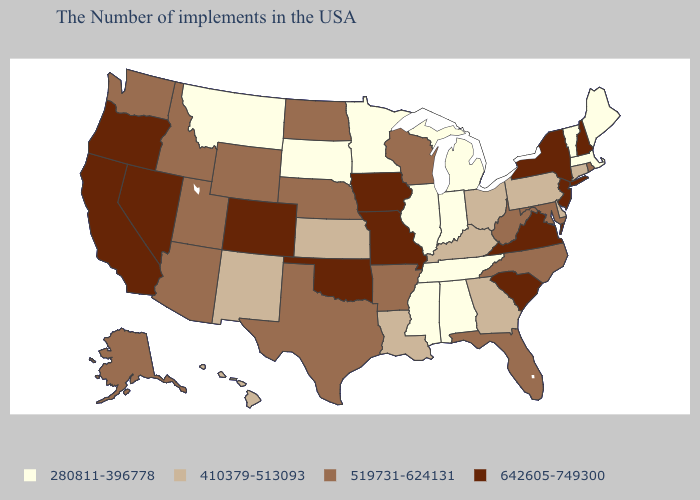What is the highest value in states that border Texas?
Keep it brief. 642605-749300. Name the states that have a value in the range 642605-749300?
Write a very short answer. New Hampshire, New York, New Jersey, Virginia, South Carolina, Missouri, Iowa, Oklahoma, Colorado, Nevada, California, Oregon. Does Virginia have the highest value in the USA?
Concise answer only. Yes. What is the value of New Jersey?
Write a very short answer. 642605-749300. Does Delaware have a higher value than Pennsylvania?
Be succinct. No. What is the value of California?
Quick response, please. 642605-749300. What is the value of Nebraska?
Concise answer only. 519731-624131. What is the value of Alabama?
Answer briefly. 280811-396778. Does Wisconsin have the same value as Georgia?
Short answer required. No. Name the states that have a value in the range 410379-513093?
Quick response, please. Connecticut, Delaware, Pennsylvania, Ohio, Georgia, Kentucky, Louisiana, Kansas, New Mexico, Hawaii. What is the lowest value in the West?
Short answer required. 280811-396778. Among the states that border Arizona , which have the highest value?
Write a very short answer. Colorado, Nevada, California. Name the states that have a value in the range 280811-396778?
Write a very short answer. Maine, Massachusetts, Vermont, Michigan, Indiana, Alabama, Tennessee, Illinois, Mississippi, Minnesota, South Dakota, Montana. Among the states that border South Carolina , which have the highest value?
Short answer required. North Carolina. 